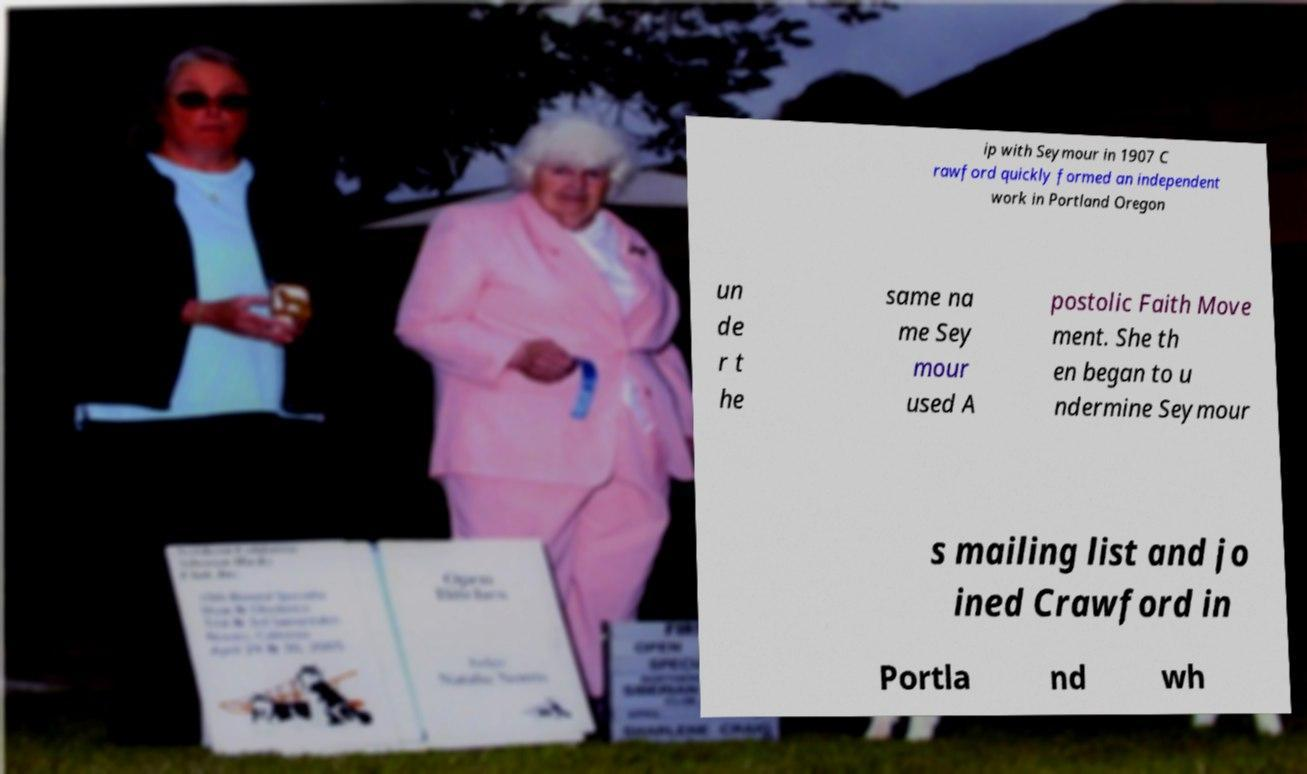Please identify and transcribe the text found in this image. ip with Seymour in 1907 C rawford quickly formed an independent work in Portland Oregon un de r t he same na me Sey mour used A postolic Faith Move ment. She th en began to u ndermine Seymour s mailing list and jo ined Crawford in Portla nd wh 